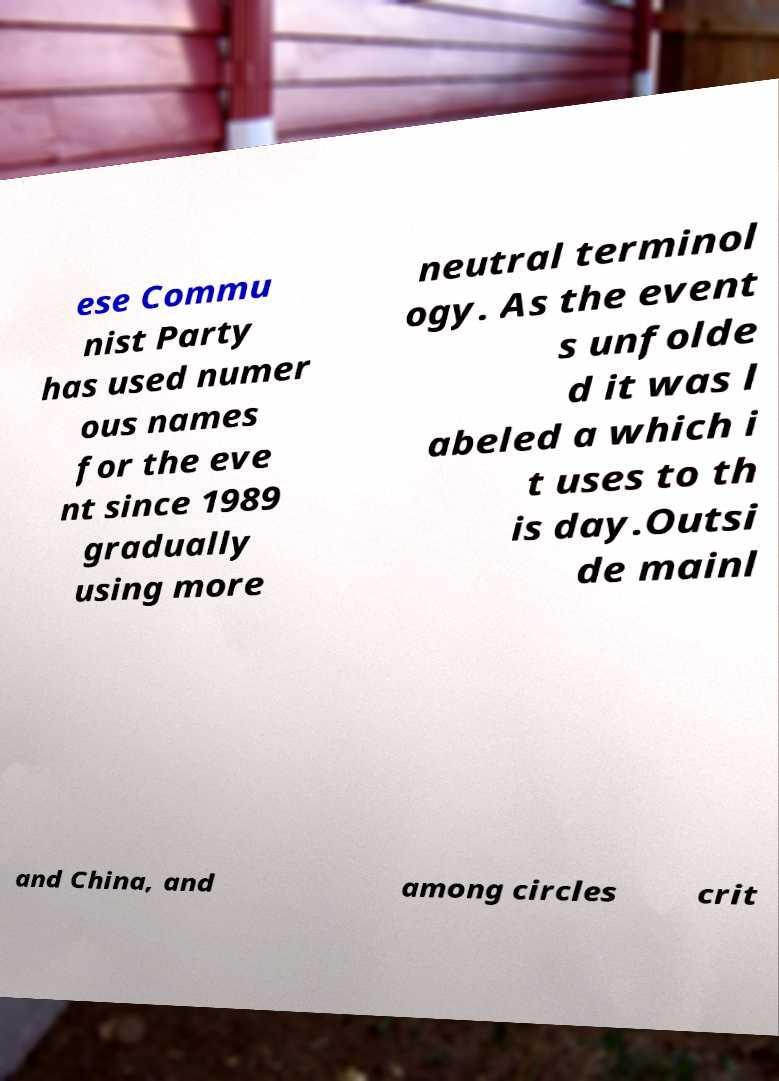Can you accurately transcribe the text from the provided image for me? ese Commu nist Party has used numer ous names for the eve nt since 1989 gradually using more neutral terminol ogy. As the event s unfolde d it was l abeled a which i t uses to th is day.Outsi de mainl and China, and among circles crit 